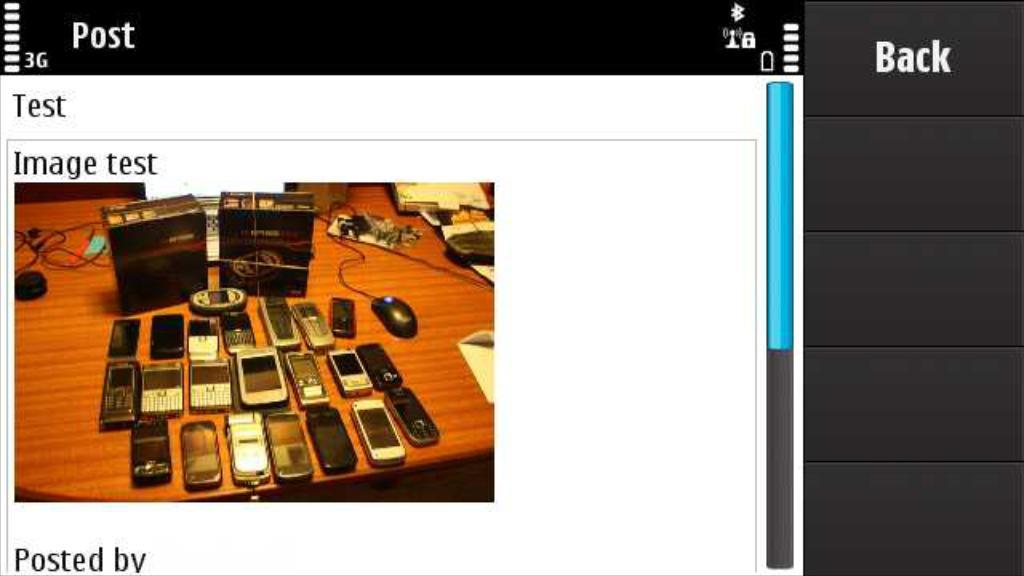<image>
Describe the image concisely. A screen shot of a test image of many electronics. 